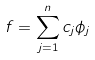<formula> <loc_0><loc_0><loc_500><loc_500>f = \sum _ { j = 1 } ^ { n } c _ { j } \phi _ { j }</formula> 